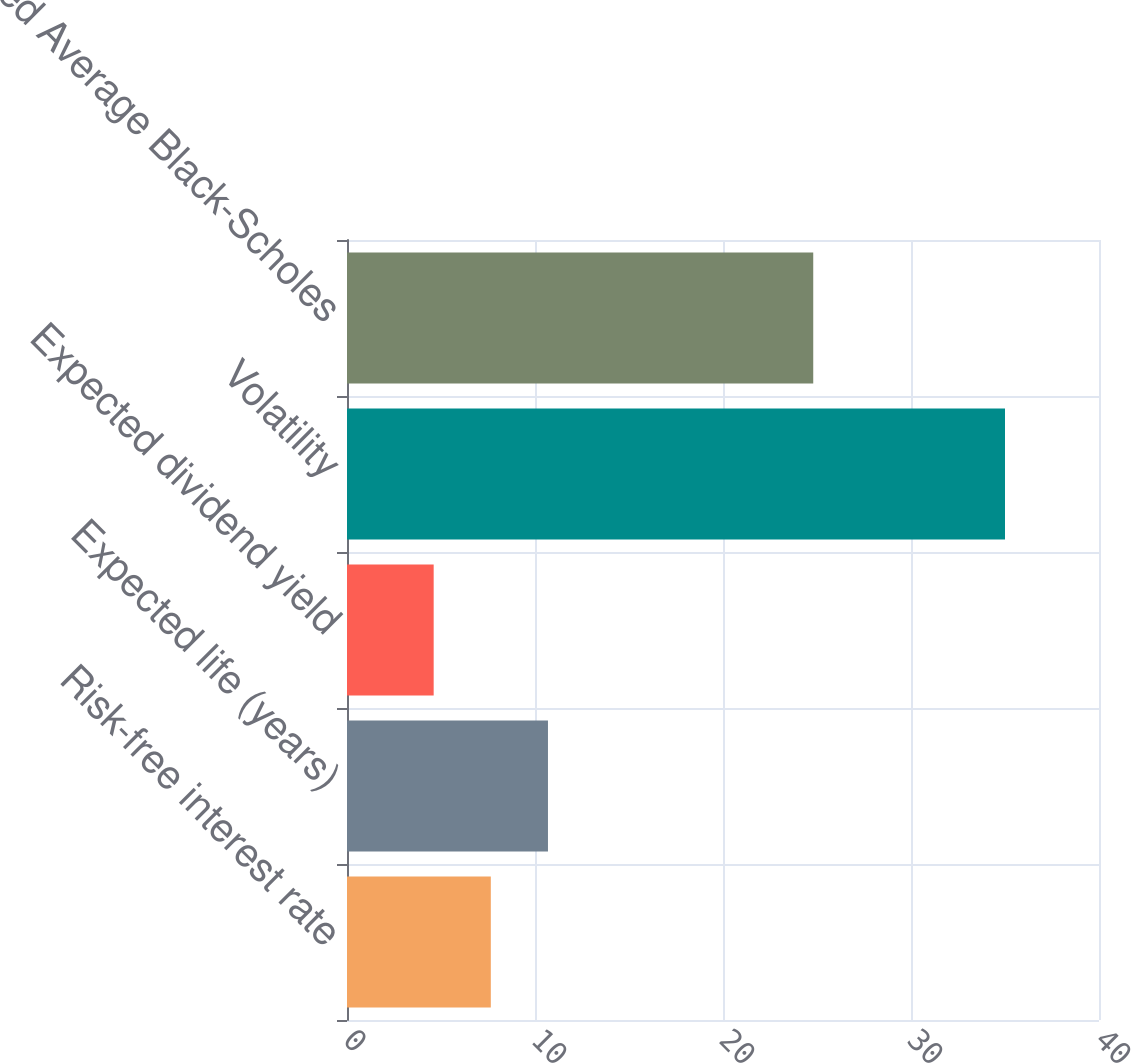Convert chart. <chart><loc_0><loc_0><loc_500><loc_500><bar_chart><fcel>Risk-free interest rate<fcel>Expected life (years)<fcel>Expected dividend yield<fcel>Volatility<fcel>Weighted Average Black-Scholes<nl><fcel>7.65<fcel>10.69<fcel>4.61<fcel>35<fcel>24.8<nl></chart> 